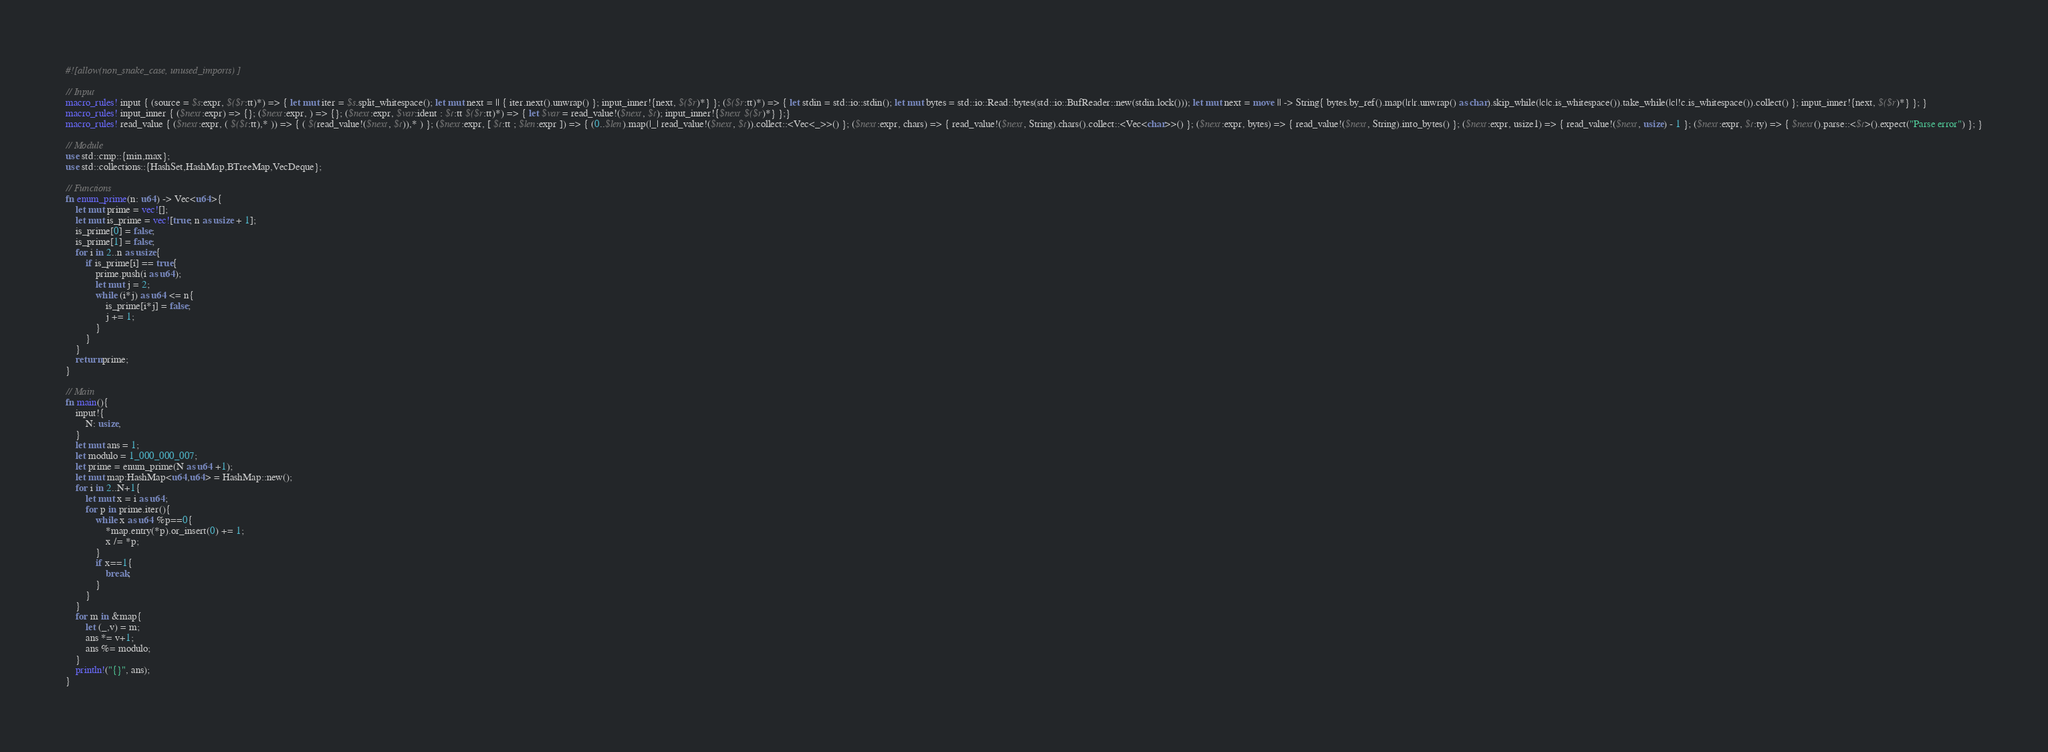Convert code to text. <code><loc_0><loc_0><loc_500><loc_500><_Rust_>#![allow(non_snake_case, unused_imports)]

// Input
macro_rules! input { (source = $s:expr, $($r:tt)*) => { let mut iter = $s.split_whitespace(); let mut next = || { iter.next().unwrap() }; input_inner!{next, $($r)*} }; ($($r:tt)*) => { let stdin = std::io::stdin(); let mut bytes = std::io::Read::bytes(std::io::BufReader::new(stdin.lock())); let mut next = move || -> String{ bytes.by_ref().map(|r|r.unwrap() as char).skip_while(|c|c.is_whitespace()).take_while(|c|!c.is_whitespace()).collect() }; input_inner!{next, $($r)*} }; }
macro_rules! input_inner { ($next:expr) => {}; ($next:expr, ) => {}; ($next:expr, $var:ident : $t:tt $($r:tt)*) => { let $var = read_value!($next, $t); input_inner!{$next $($r)*} };}
macro_rules! read_value { ($next:expr, ( $($t:tt),* )) => { ( $(read_value!($next, $t)),* ) }; ($next:expr, [ $t:tt ; $len:expr ]) => { (0..$len).map(|_| read_value!($next, $t)).collect::<Vec<_>>() }; ($next:expr, chars) => { read_value!($next, String).chars().collect::<Vec<char>>() }; ($next:expr, bytes) => { read_value!($next, String).into_bytes() }; ($next:expr, usize1) => { read_value!($next, usize) - 1 }; ($next:expr, $t:ty) => { $next().parse::<$t>().expect("Parse error") }; }

// Module
use std::cmp::{min,max};
use std::collections::{HashSet,HashMap,BTreeMap,VecDeque};

// Functions
fn enum_prime(n: u64) -> Vec<u64>{
    let mut prime = vec![];
    let mut is_prime = vec![true; n as usize + 1];
    is_prime[0] = false;
    is_prime[1] = false;
    for i in 2..n as usize{
        if is_prime[i] == true{
            prime.push(i as u64);
            let mut j = 2;
            while (i*j) as u64 <= n{
                is_prime[i*j] = false;
                j += 1;
            }
        }
    }
    return prime;
}

// Main
fn main(){
    input!{
        N: usize,
    }
    let mut ans = 1;
    let modulo = 1_000_000_007;
    let prime = enum_prime(N as u64 +1);
    let mut map:HashMap<u64,u64> = HashMap::new();
    for i in 2..N+1{
        let mut x = i as u64;
        for p in prime.iter(){
            while x as u64 %p==0{
                *map.entry(*p).or_insert(0) += 1;
                x /= *p;
            }
            if x==1{
                break;
            }
        }
    }
    for m in &map{
        let (_,v) = m;
        ans *= v+1;
        ans %= modulo;
    }
    println!("{}", ans);
}</code> 